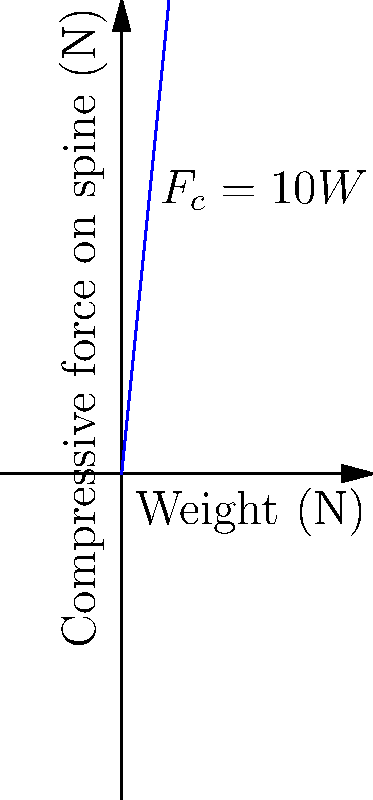In labor contract negotiations for warehouse workers, you need to address safety concerns related to lifting heavy objects. Given that the compressive force ($F_c$) on a worker's spine is approximately 10 times the weight ($W$) of the object being lifted, as shown in the graph, what is the maximum weight a worker should lift to keep the compressive force below 3400 N, which is considered a safe limit for most adults? To solve this problem, we need to follow these steps:

1. Understand the relationship between weight and compressive force:
   $F_c = 10W$, where $F_c$ is the compressive force and $W$ is the weight of the object.

2. Identify the safe limit for compressive force:
   The safe limit is given as 3400 N.

3. Set up an equation using the safe limit:
   $3400 = 10W$

4. Solve for $W$:
   $W = 3400 \div 10 = 340$ N

5. Convert to kilograms (optional, for practical use):
   340 N ≈ 34.7 kg (using the approximation that 1 kg ≈ 9.8 N)

Therefore, to keep the compressive force below 3400 N, the maximum weight a worker should lift is 340 N or approximately 34.7 kg.
Answer: 340 N (or 34.7 kg) 